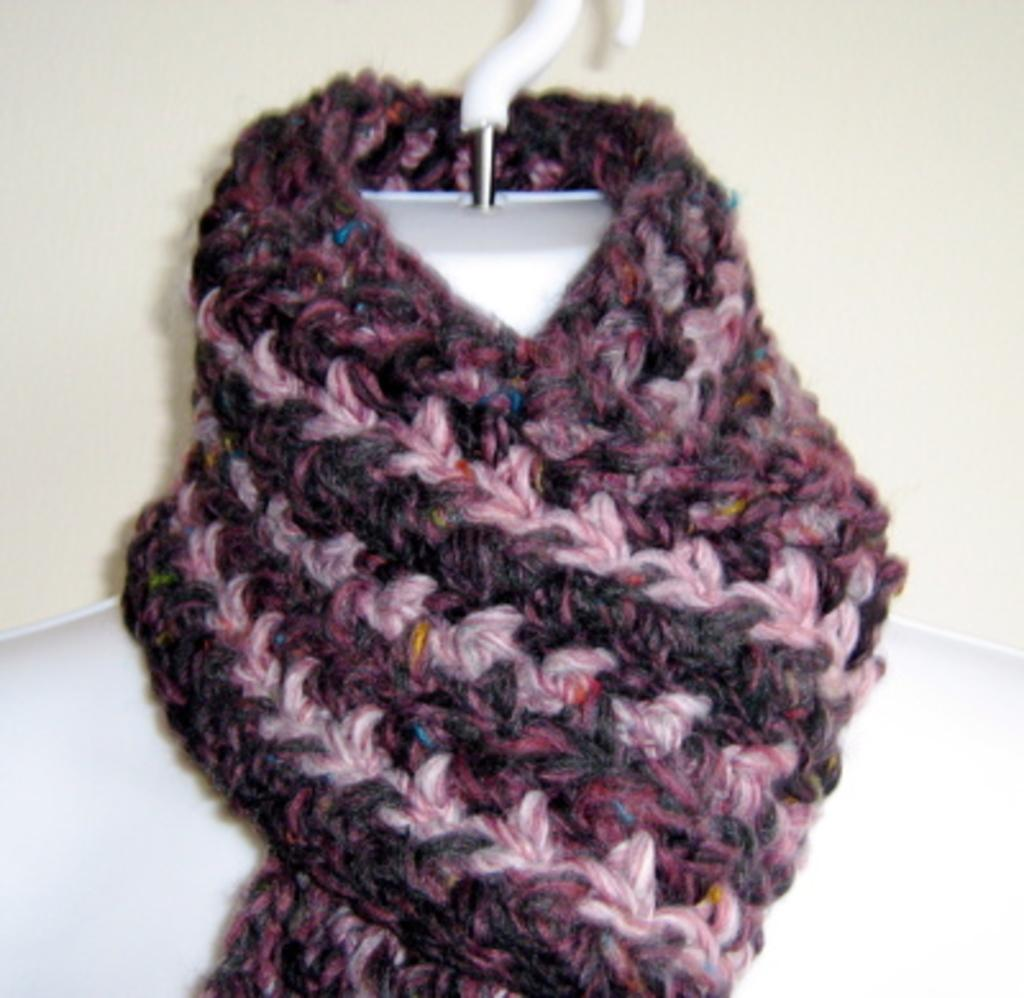What is placed on the mannequin in the image? There is a cloth on the mannequin's neck in the image. What can be seen in the background of the image? There is a wall visible in the background of the image. What type of turkey can be seen crawling on the wall in the image? There is no turkey present in the image, and the wall does not show any crawling animals. 